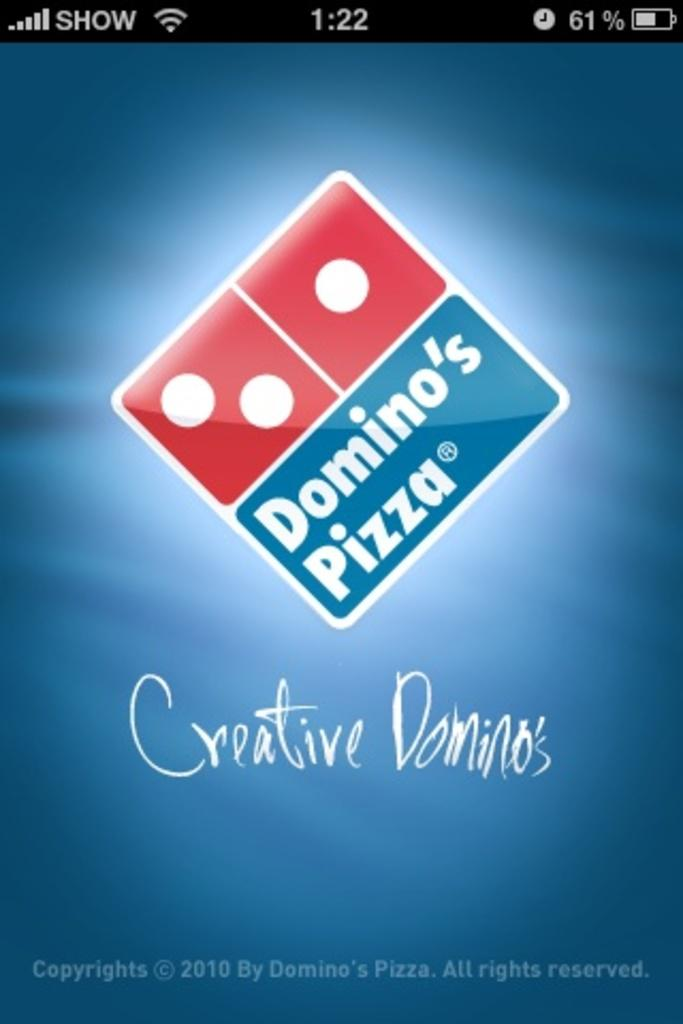<image>
Render a clear and concise summary of the photo. Phone screen showing Domino's Pizza and the year 2010. 